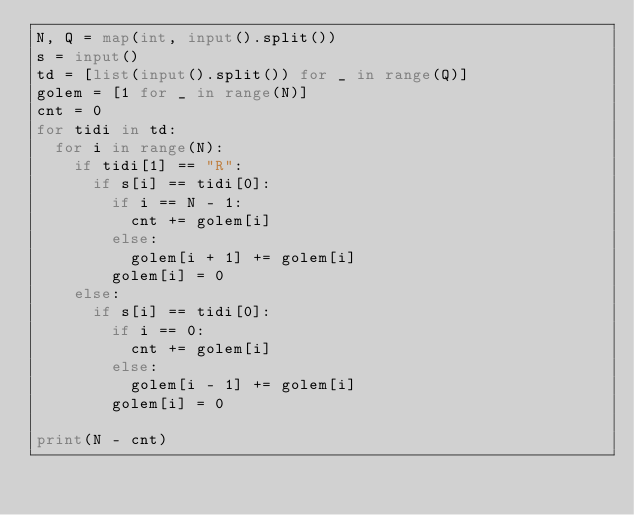Convert code to text. <code><loc_0><loc_0><loc_500><loc_500><_Python_>N, Q = map(int, input().split())
s = input()
td = [list(input().split()) for _ in range(Q)]
golem = [1 for _ in range(N)]
cnt = 0
for tidi in td:
  for i in range(N):
    if tidi[1] == "R":
      if s[i] == tidi[0]:
        if i == N - 1:
          cnt += golem[i]
        else:
          golem[i + 1] += golem[i]
        golem[i] = 0
    else:
      if s[i] == tidi[0]:
        if i == 0:
          cnt += golem[i]
        else:
          golem[i - 1] += golem[i]
        golem[i] = 0

print(N - cnt)</code> 